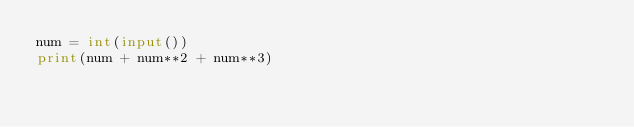<code> <loc_0><loc_0><loc_500><loc_500><_Python_>num = int(input())
print(num + num**2 + num**3)</code> 